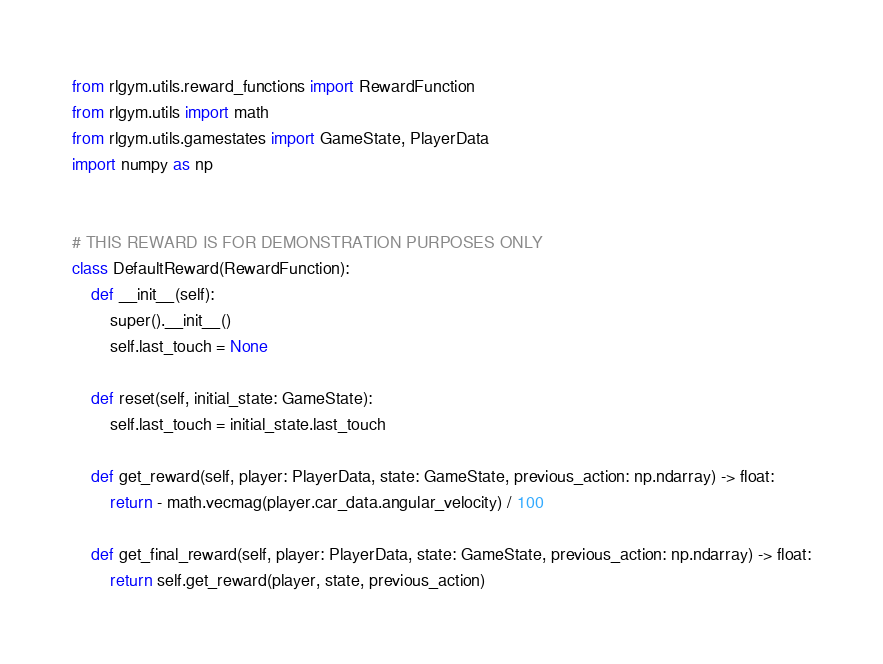<code> <loc_0><loc_0><loc_500><loc_500><_Python_>from rlgym.utils.reward_functions import RewardFunction
from rlgym.utils import math
from rlgym.utils.gamestates import GameState, PlayerData
import numpy as np


# THIS REWARD IS FOR DEMONSTRATION PURPOSES ONLY
class DefaultReward(RewardFunction):
    def __init__(self):
        super().__init__()
        self.last_touch = None

    def reset(self, initial_state: GameState):
        self.last_touch = initial_state.last_touch

    def get_reward(self, player: PlayerData, state: GameState, previous_action: np.ndarray) -> float:
        return - math.vecmag(player.car_data.angular_velocity) / 100

    def get_final_reward(self, player: PlayerData, state: GameState, previous_action: np.ndarray) -> float:
        return self.get_reward(player, state, previous_action)
</code> 